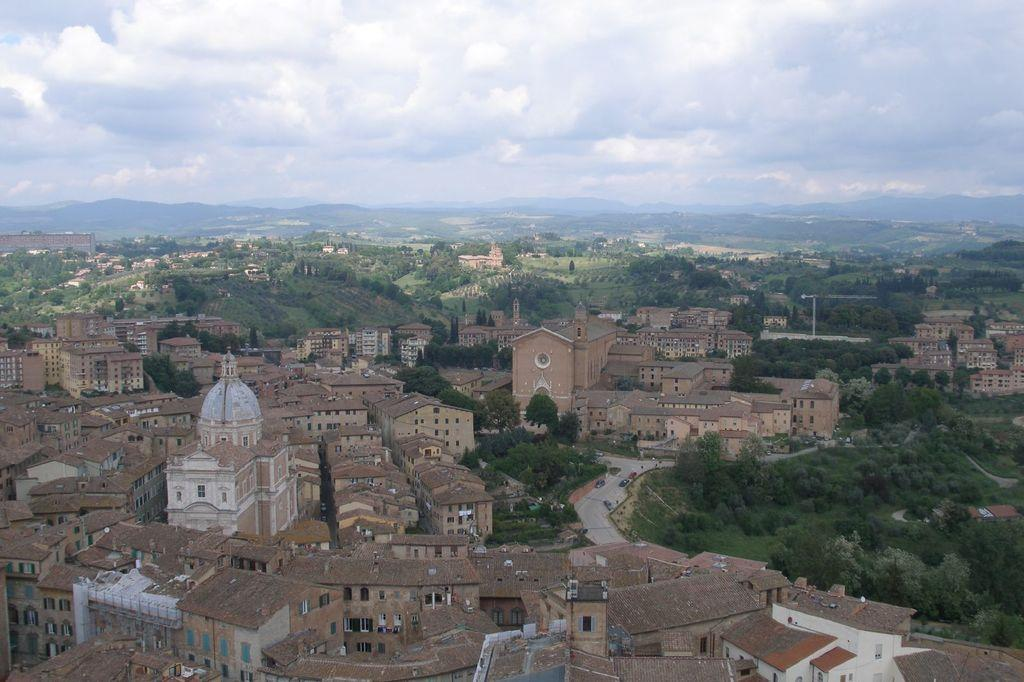What type of structures can be seen in the image? There are many buildings in the image. What other natural elements are present in the image? There are trees in the image. What can be seen in the distance in the background of the image? There are mountains in the background of the image. What is visible in the sky in the image? Clouds are visible in the sky. Where is the drum located in the image? There is no drum present in the image. What type of animal can be seen interacting with the trees in the image? There is no animal, such as a squirrel, present in the image. 